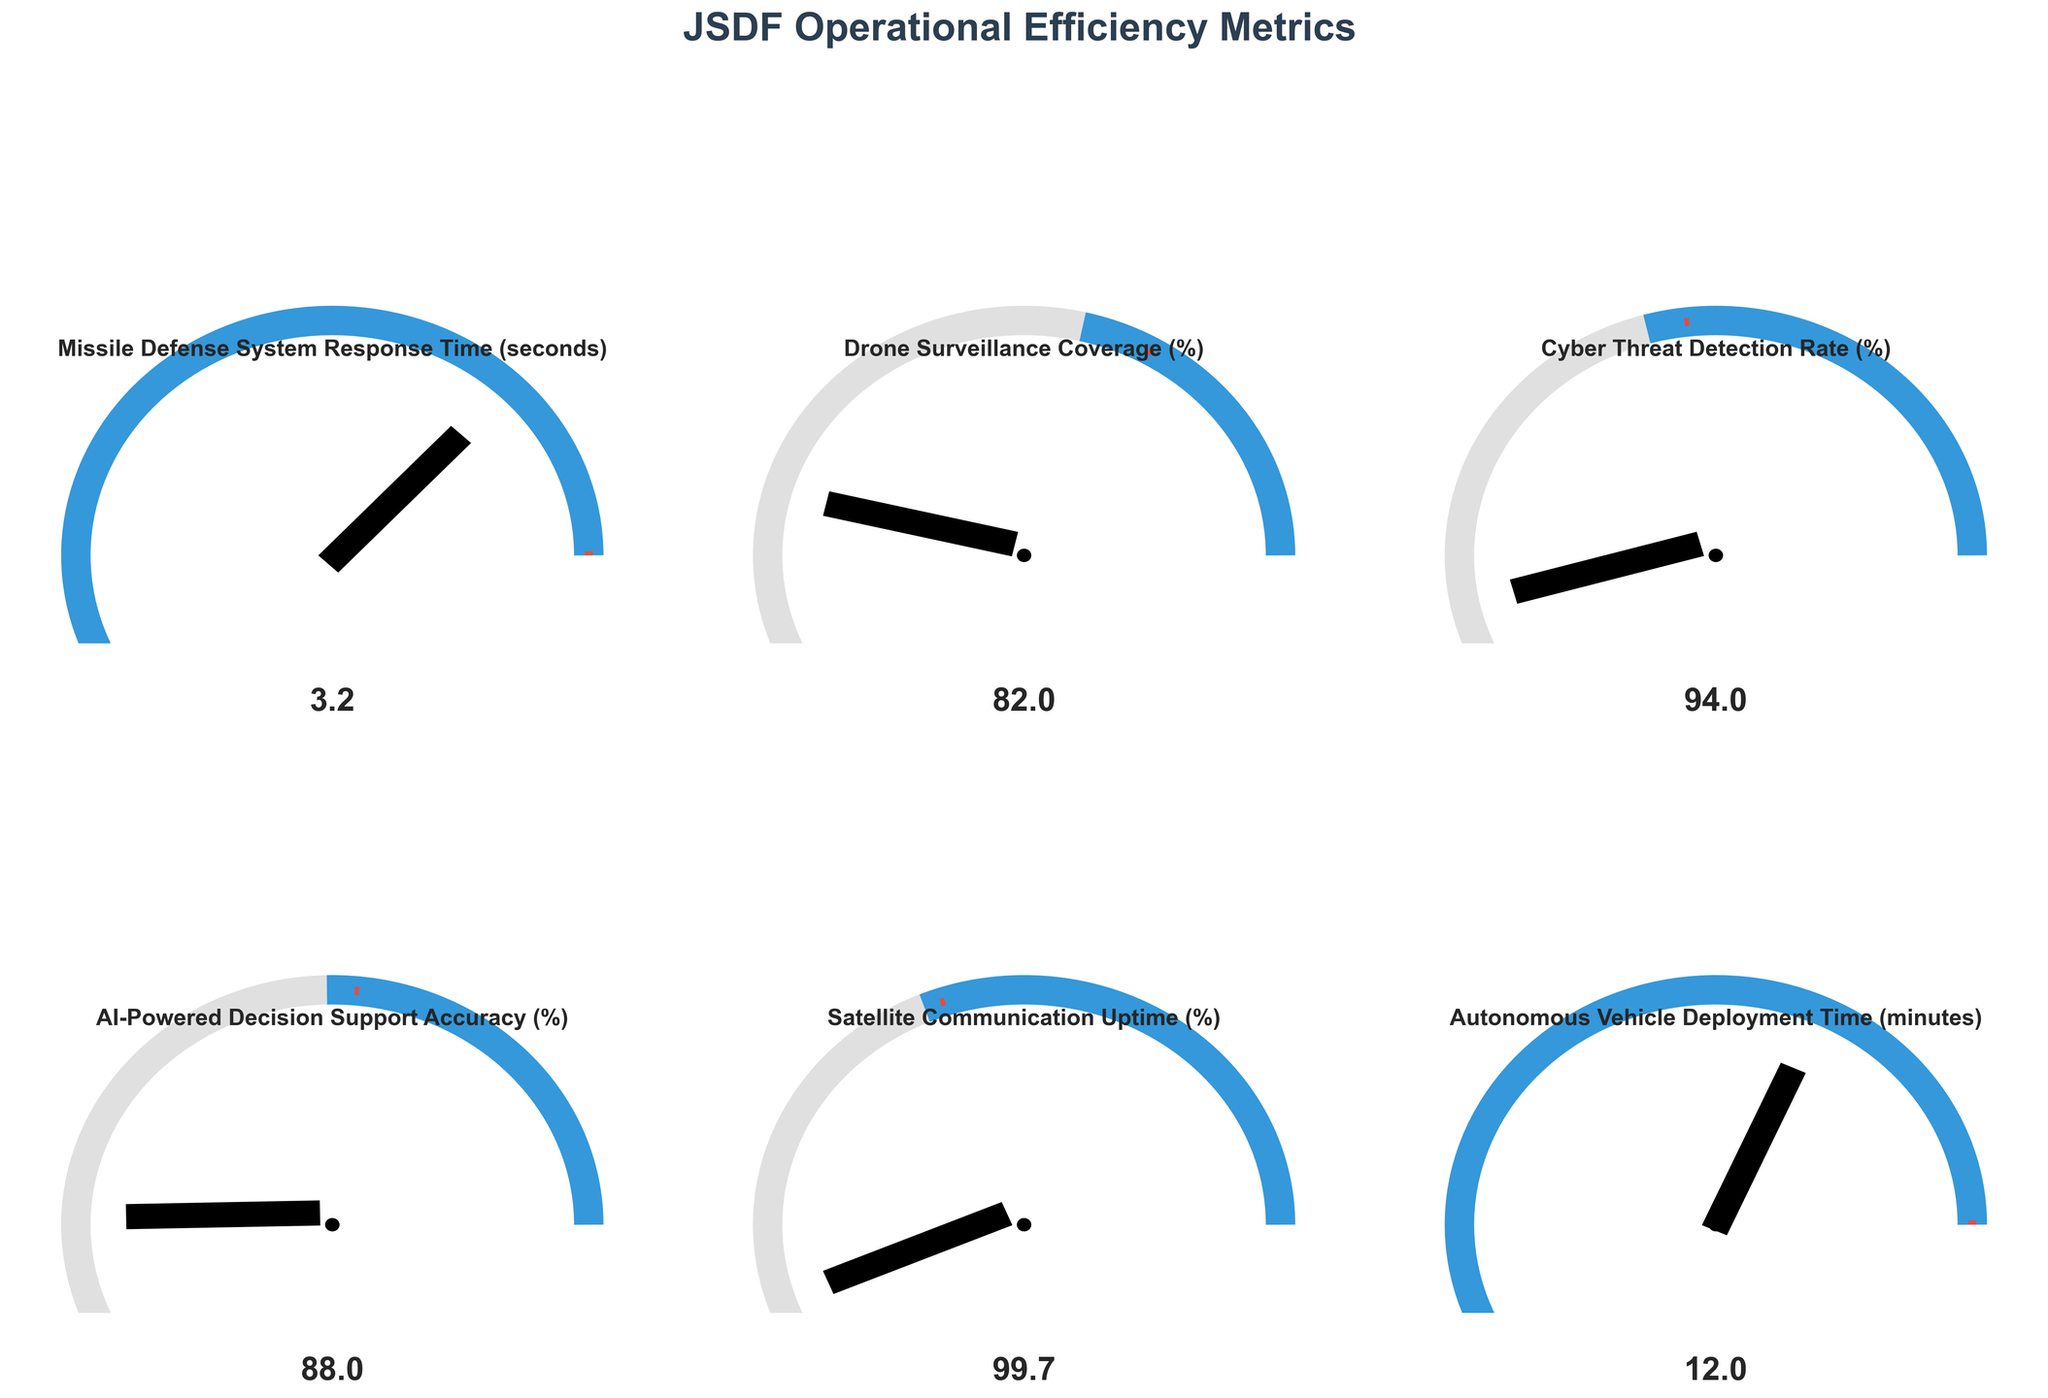What's the title of the figure? The title is displayed at the top of the figure, and it reads 'JSDF Operational Efficiency Metrics'.
Answer: JSDF Operational Efficiency Metrics Which operational metric has the highest value? By observing the values shown on the gauge charts, the Satellite Communication Uptime (%) has the highest value of 99.7.
Answer: Satellite Communication Uptime (%) Does the Missile Defense System Response Time (seconds) meet its benchmark target? The benchmark for the Missile Defense System Response Time is 5 seconds, and the actual value is 3.2 seconds. Since 3.2 seconds is less than 5 seconds, it meets the benchmark.
Answer: Yes What is the difference between the benchmark and the actual value of the Cyber Threat Detection Rate (%)? The benchmark for Cyber Threat Detection Rate (%) is 90%, and the actual value is 94%. The difference is 94% - 90% = 4%.
Answer: 4% Which metric exceeds its benchmark by the largest margin? To determine this, we subtract the benchmark from the actual value for each metric: 
Missile Defense System Response Time: not applicable (benchmark is higher),
Drone Surveillance Coverage: 82% - 75% = 7%,
Cyber Threat Detection Rate: 94% - 90% = 4%,
AI-Powered Decision Support Accuracy: 88% - 85% = 3%,
Satellite Communication Uptime: 99.7% - 99.5% = 0.2%,
Autonomous Vehicle Deployment Time: not applicable (benchmark is higher).
So, Drone Surveillance Coverage exceeds its benchmark by the largest margin.
Answer: Drone Surveillance Coverage (%) How many metrics do not meet their benchmark targets? We have six metrics in total. By comparing the actual values with the benchmarks: 
Missile Defense System Response Time (3.2 < 5), meets
Drone Surveillance Coverage (82 > 75), meets
Cyber Threat Detection Rate (94 > 90), meets
AI-Powered Decision Support Accuracy (88 > 85), meets
Satellite Communication Uptime (99.7 > 99.5), meets
Autonomous Vehicle Deployment Time (12 < 15), meets.
None of the metrics fail to meet their benchmark targets.
Answer: 0 What value is displayed for the metric 'Autonomous Vehicle Deployment Time'? The value displayed on the gauge chart for 'Autonomous Vehicle Deployment Time' is 12 minutes.
Answer: 12 minutes Which metric has the smallest difference from its benchmark? Subtracting the benchmark from the actual value for each metric: 
Missile Defense System Response Time: not applicable (benchmark is higher),
Drone Surveillance Coverage: 82% - 75% = 7%,
Cyber Threat Detection Rate: 94% - 90% = 4%,
AI-Powered Decision Support Accuracy: 88% - 85% = 3%,
Satellite Communication Uptime: 99.7% - 99.5% = 0.2%,
Autonomous Vehicle Deployment Time: not applicable (benchmark is higher).
The Satellite Communication Uptime has the smallest difference from its benchmark, which is 0.2%.
Answer: Satellite Communication Uptime (%) 